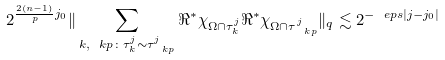<formula> <loc_0><loc_0><loc_500><loc_500>2 ^ { \frac { 2 ( n - 1 ) } { p } j _ { 0 } } \| \sum _ { k , \ k p \colon \tau ^ { j } _ { k } \sim \tau ^ { j } _ { \ k p } } \Re ^ { * } \chi _ { \Omega \cap \tau ^ { j } _ { k } } \Re ^ { * } \chi _ { \Omega \cap \tau ^ { j } _ { \ k p } } \| _ { q } \lesssim 2 ^ { - \ e p s | j - j _ { 0 } | }</formula> 